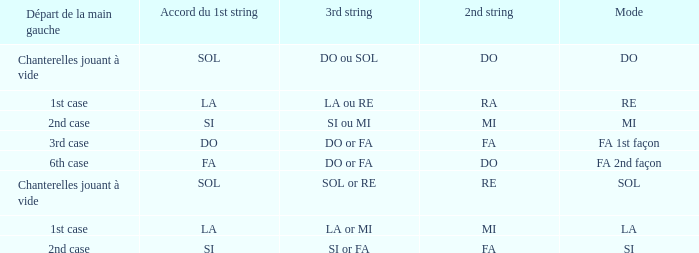Would you mind parsing the complete table? {'header': ['Départ de la main gauche', 'Accord du 1st string', '3rd string', '2nd string', 'Mode'], 'rows': [['Chanterelles jouant à vide', 'SOL', 'DO ou SOL', 'DO', 'DO'], ['1st case', 'LA', 'LA ou RE', 'RA', 'RE'], ['2nd case', 'SI', 'SI ou MI', 'MI', 'MI'], ['3rd case', 'DO', 'DO or FA', 'FA', 'FA 1st façon'], ['6th case', 'FA', 'DO or FA', 'DO', 'FA 2nd façon'], ['Chanterelles jouant à vide', 'SOL', 'SOL or RE', 'RE', 'SOL'], ['1st case', 'LA', 'LA or MI', 'MI', 'LA'], ['2nd case', 'SI', 'SI or FA', 'FA', 'SI']]} For a 1st string of si Accord du and a 2nd string of mi what is the 3rd string? SI ou MI. 